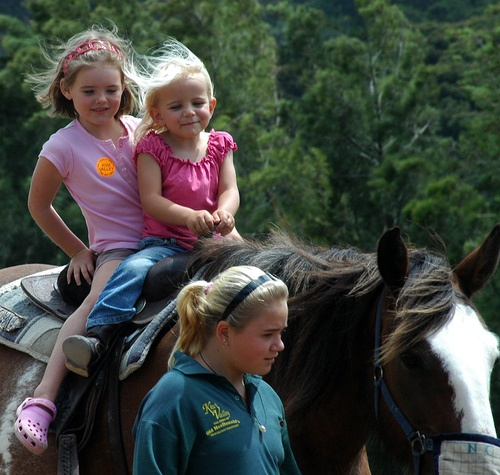Describe the objects in this image and their specific colors. I can see horse in navy, black, gray, white, and darkgray tones, people in navy, black, blue, maroon, and darkblue tones, people in navy, gray, and darkgray tones, and people in navy, maroon, gray, white, and black tones in this image. 